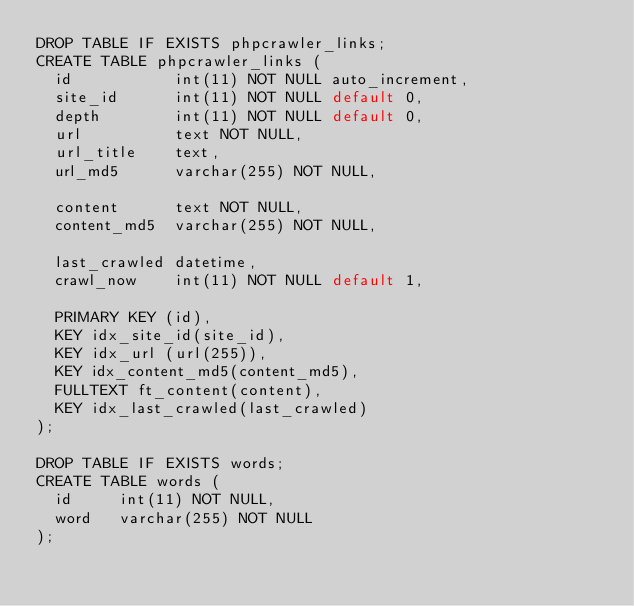Convert code to text. <code><loc_0><loc_0><loc_500><loc_500><_SQL_>DROP TABLE IF EXISTS phpcrawler_links;
CREATE TABLE phpcrawler_links (
  id           int(11) NOT NULL auto_increment,
  site_id      int(11) NOT NULL default 0,
  depth        int(11) NOT NULL default 0,
  url          text NOT NULL,
  url_title    text,
  url_md5      varchar(255) NOT NULL,

  content      text NOT NULL,
  content_md5  varchar(255) NOT NULL,

  last_crawled datetime,
  crawl_now    int(11) NOT NULL default 1,
  
  PRIMARY KEY (id),
  KEY idx_site_id(site_id),
  KEY idx_url (url(255)),
  KEY idx_content_md5(content_md5),
  FULLTEXT ft_content(content),
  KEY idx_last_crawled(last_crawled)
);

DROP TABLE IF EXISTS words;
CREATE TABLE words (
  id     int(11) NOT NULL,
  word   varchar(255) NOT NULL
);
</code> 